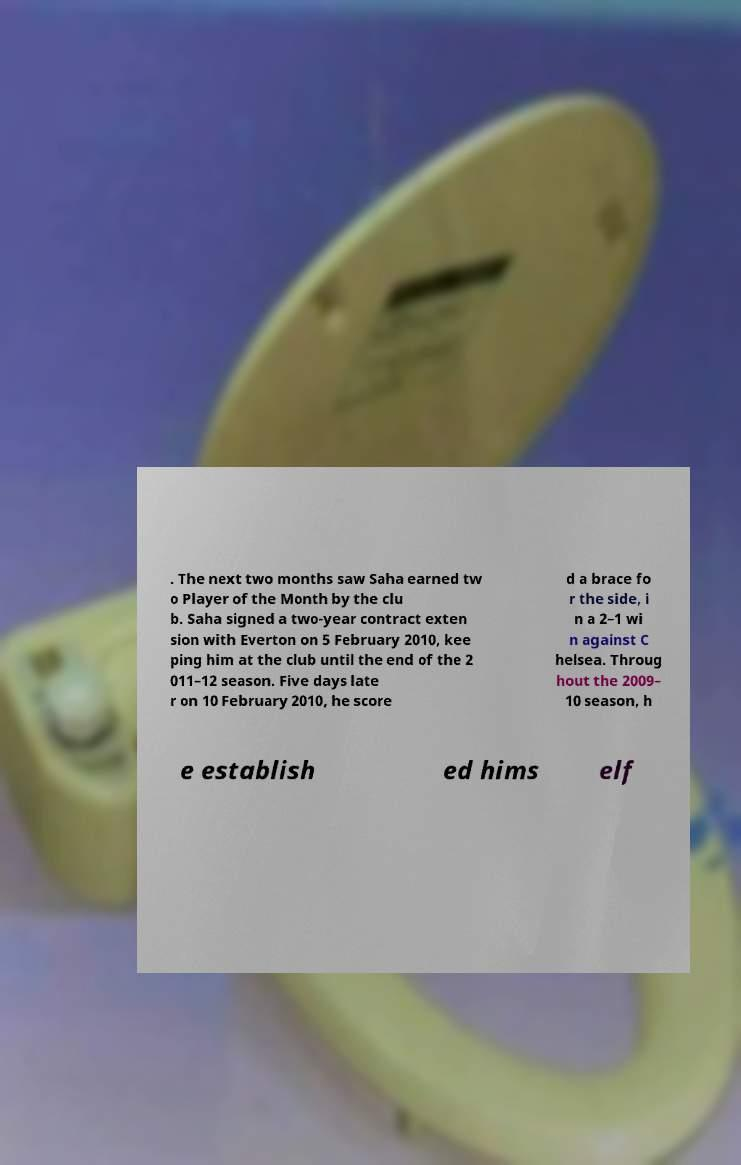For documentation purposes, I need the text within this image transcribed. Could you provide that? . The next two months saw Saha earned tw o Player of the Month by the clu b. Saha signed a two-year contract exten sion with Everton on 5 February 2010, kee ping him at the club until the end of the 2 011–12 season. Five days late r on 10 February 2010, he score d a brace fo r the side, i n a 2–1 wi n against C helsea. Throug hout the 2009– 10 season, h e establish ed hims elf 